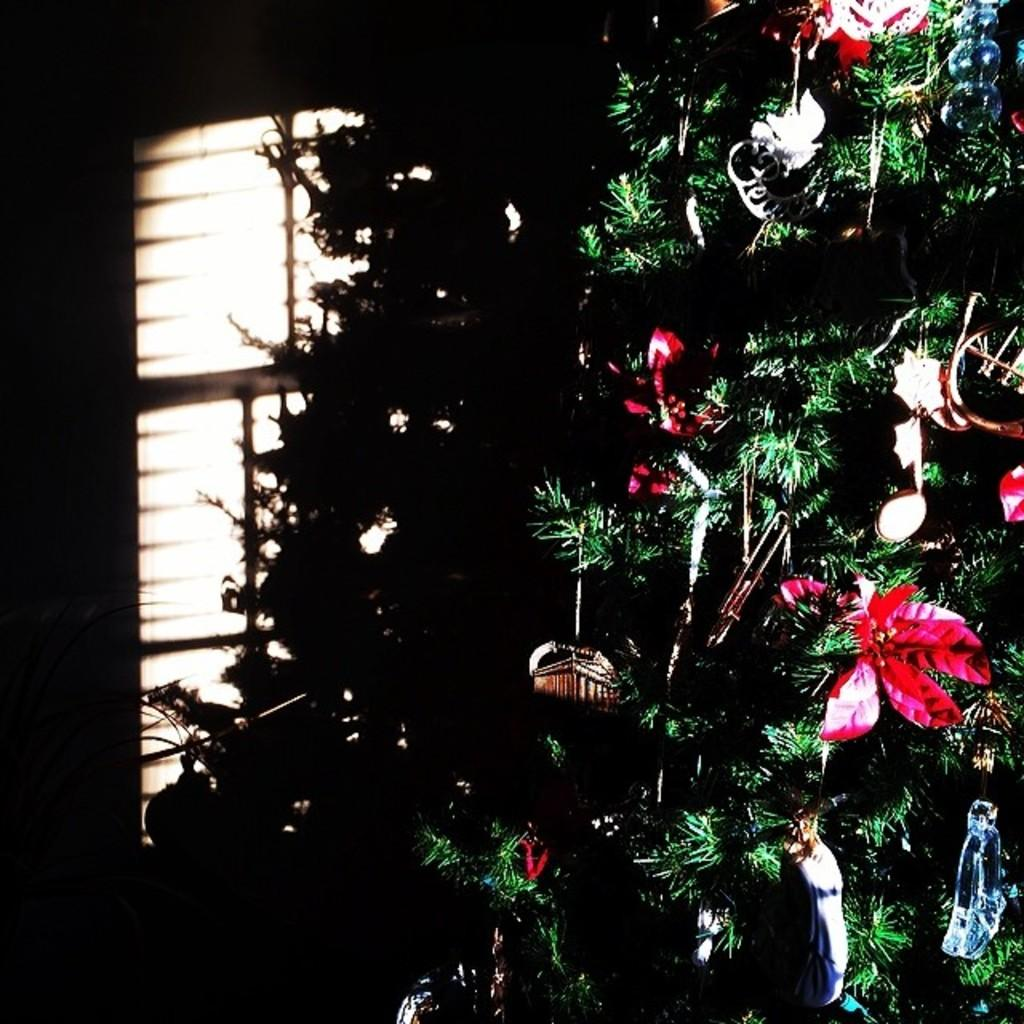What is the main subject of the image? There is a Christmas tree in the image. What can be seen on the Christmas tree? The Christmas tree has decorative items hanging on it. What is visible in the background of the image? There is a wall in the background of the image. Can you describe the wall in the background? There is a window in the wall in the background of the image. How many snails can be seen crawling on the Christmas tree in the image? There are no snails present on the Christmas tree in the image. What type of expansion is visible on the Christmas tree in the image? There is no expansion visible on the Christmas tree in the image; it is a stationary object. 